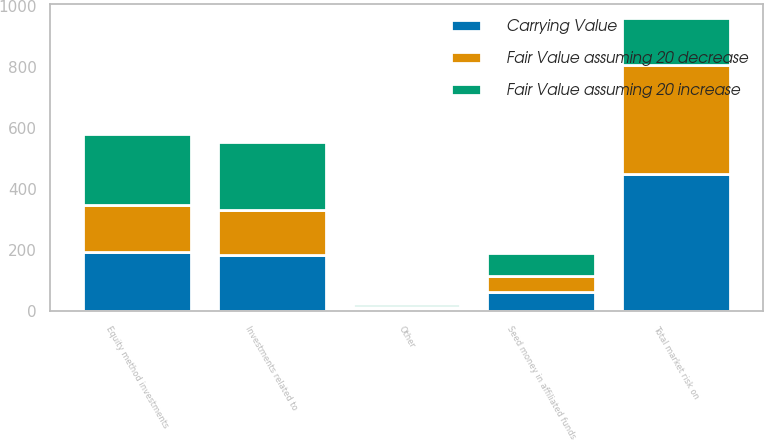<chart> <loc_0><loc_0><loc_500><loc_500><stacked_bar_chart><ecel><fcel>Investments related to<fcel>Seed money in affiliated funds<fcel>Equity method investments<fcel>Other<fcel>Total market risk on<nl><fcel>Carrying Value<fcel>184.4<fcel>63.5<fcel>193.1<fcel>8.2<fcel>449.2<nl><fcel>Fair Value assuming 20 increase<fcel>221.3<fcel>76.2<fcel>231.7<fcel>9.8<fcel>151<nl><fcel>Fair Value assuming 20 decrease<fcel>147.5<fcel>50.8<fcel>154.5<fcel>6.6<fcel>359.4<nl></chart> 